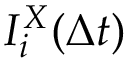<formula> <loc_0><loc_0><loc_500><loc_500>I _ { i } ^ { X } ( \Delta t )</formula> 